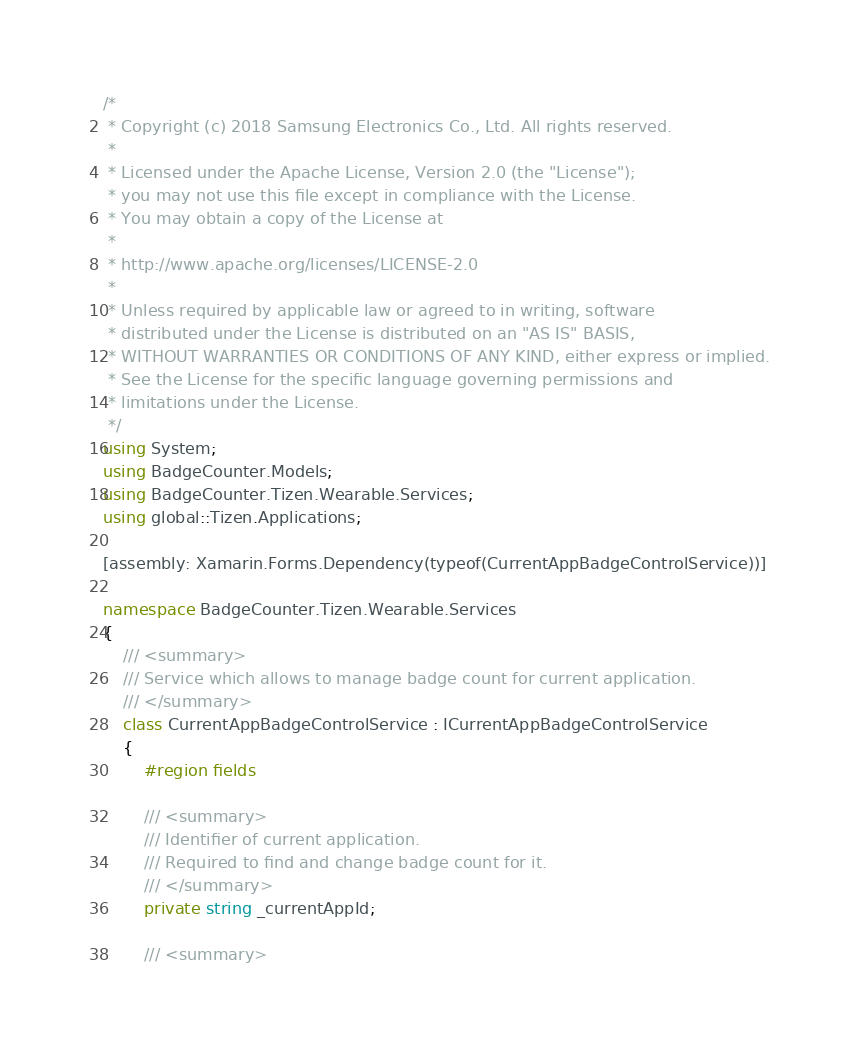<code> <loc_0><loc_0><loc_500><loc_500><_C#_>/*
 * Copyright (c) 2018 Samsung Electronics Co., Ltd. All rights reserved.
 *
 * Licensed under the Apache License, Version 2.0 (the "License");
 * you may not use this file except in compliance with the License.
 * You may obtain a copy of the License at
 *
 * http://www.apache.org/licenses/LICENSE-2.0
 *
 * Unless required by applicable law or agreed to in writing, software
 * distributed under the License is distributed on an "AS IS" BASIS,
 * WITHOUT WARRANTIES OR CONDITIONS OF ANY KIND, either express or implied.
 * See the License for the specific language governing permissions and
 * limitations under the License.
 */
using System;
using BadgeCounter.Models;
using BadgeCounter.Tizen.Wearable.Services;
using global::Tizen.Applications;

[assembly: Xamarin.Forms.Dependency(typeof(CurrentAppBadgeControlService))]

namespace BadgeCounter.Tizen.Wearable.Services
{
    /// <summary>
    /// Service which allows to manage badge count for current application.
    /// </summary>
    class CurrentAppBadgeControlService : ICurrentAppBadgeControlService
    {
        #region fields

        /// <summary>
        /// Identifier of current application.
        /// Required to find and change badge count for it.
        /// </summary>
        private string _currentAppId;

        /// <summary></code> 